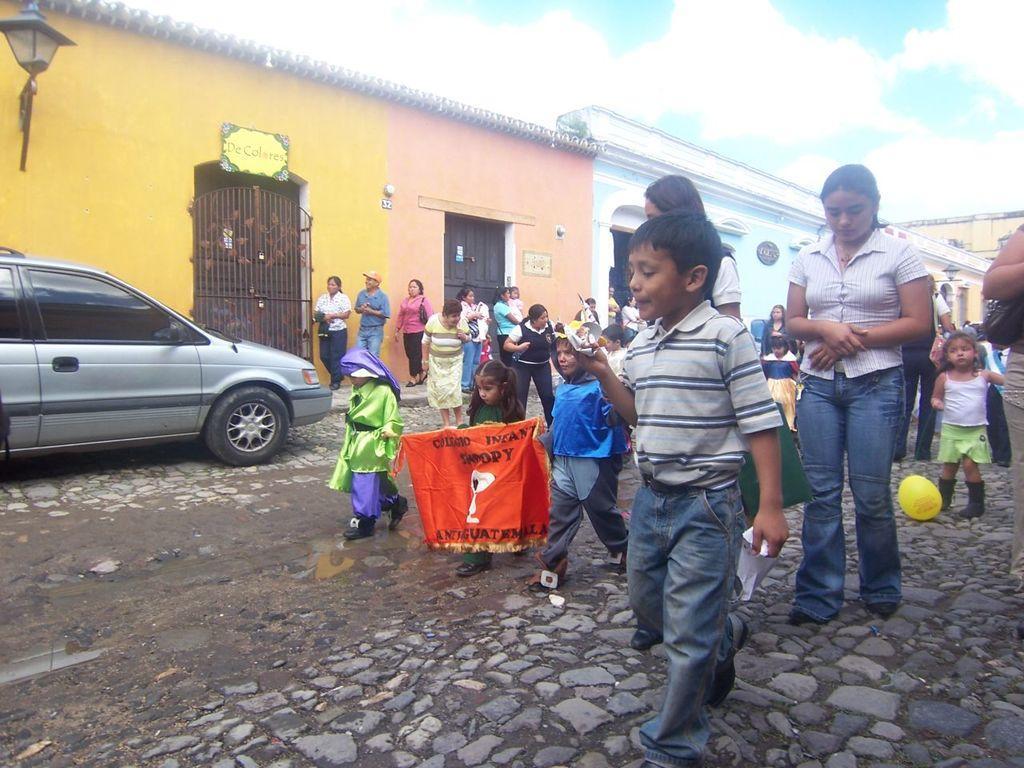Can you describe this image briefly? In this image I can see there are few persons, kids walking on the road, there is a car parked at left side. There are few buildings, it has doors and the sky is clear. 